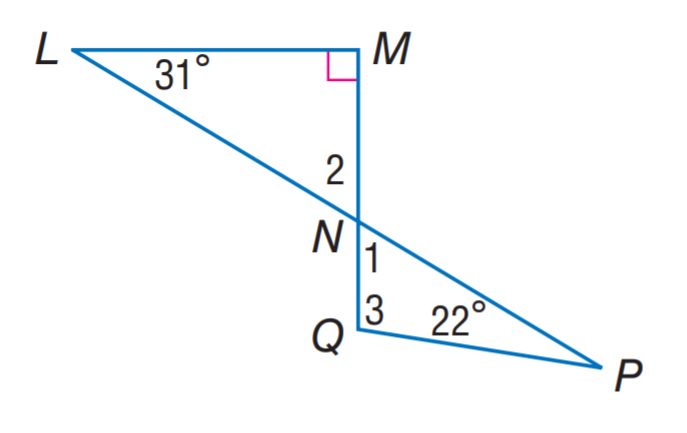Answer the mathemtical geometry problem and directly provide the correct option letter.
Question: Find m \angle 2.
Choices: A: 31 B: 42 C: 59 D: 63 C 